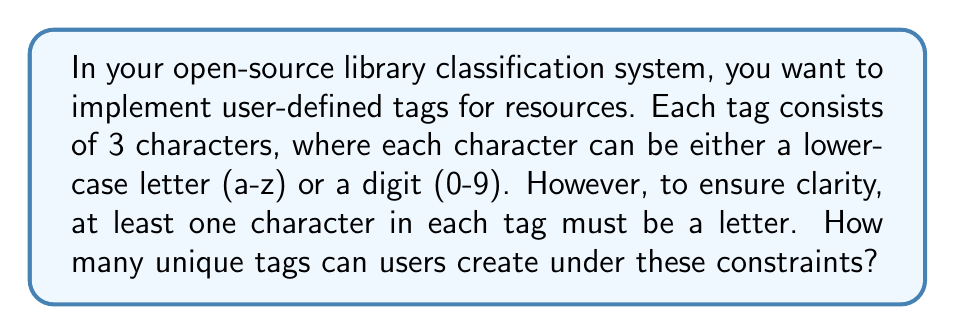Can you answer this question? Let's approach this step-by-step:

1) First, let's calculate the total number of possible 3-character combinations without any restrictions:
   $$(26 + 10)^3 = 36^3 = 46,656$$

2) Now, we need to subtract the number of tags that consist only of digits, as these are not allowed:
   $$10^3 = 1,000$$

3) Therefore, the number of valid tags is:
   $$46,656 - 1,000 = 45,656$$

We can verify this result using the inclusion-exclusion principle:

4) Let's define our sets:
   A: Tags with at least one letter in the first position
   B: Tags with at least one letter in the second position
   C: Tags with at least one letter in the third position

5) We can calculate the size of each set:
   $|A| = |B| = |C| = 26 \times 36 \times 36 = 33,696$

6) Now, let's calculate the intersections:
   $|A \cap B| = |A \cap C| = |B \cap C| = 26 \times 26 \times 36 = 24,336$
   $|A \cap B \cap C| = 26 \times 26 \times 26 = 17,576$

7) Applying the inclusion-exclusion principle:
   $$|A \cup B \cup C| = |A| + |B| + |C| - |A \cap B| - |A \cap C| - |B \cap C| + |A \cap B \cap C|$$
   $$= 33,696 + 33,696 + 33,696 - 24,336 - 24,336 - 24,336 + 17,576 = 45,656$$

This confirms our initial calculation.
Answer: $$45,656$$ 